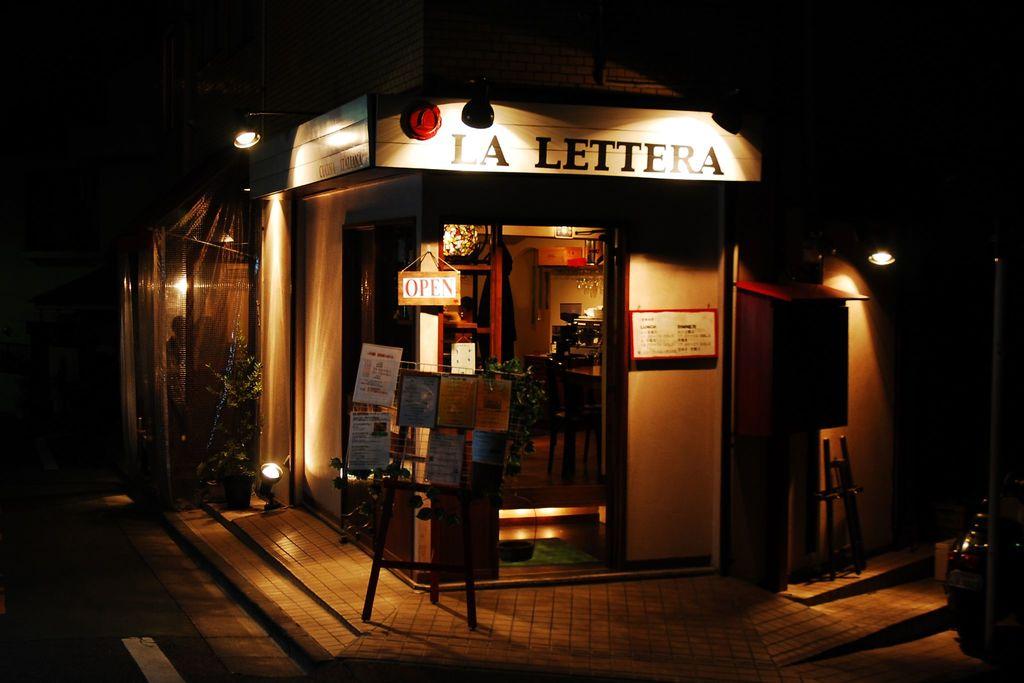What is the name of the shop?
Provide a short and direct response. La lettera. Is the shop open or closed?
Your answer should be very brief. Open. 